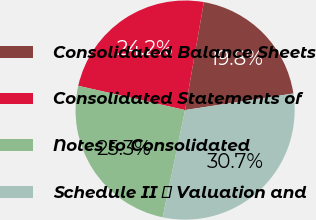<chart> <loc_0><loc_0><loc_500><loc_500><pie_chart><fcel>Consolidated Balance Sheets<fcel>Consolidated Statements of<fcel>Notes to Consolidated<fcel>Schedule II  Valuation and<nl><fcel>19.84%<fcel>24.19%<fcel>25.27%<fcel>30.7%<nl></chart> 